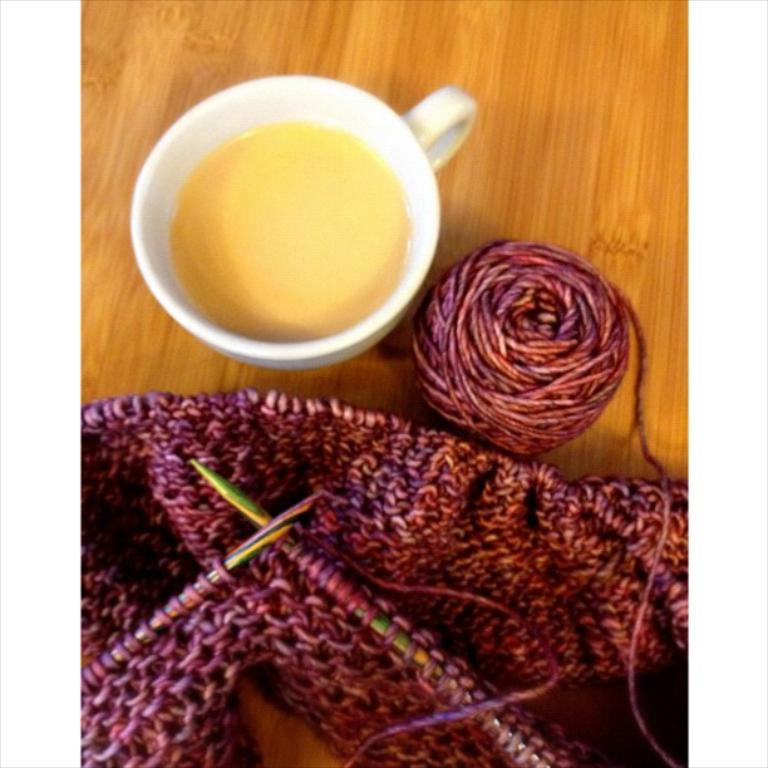What type of surface is visible in the image? There is a wooden surface in the image. What is placed on the wooden surface? There is a cup of some drink and a roll of woolen thread on the wooden surface. What else can be seen on the wooden surface? There is a woolen cloth on the wooden surface. How is the woolen cloth being held in place? There are two pins attached to the woolen cloth. What degree of difficulty is the mind experiencing in the image? There is no mention of a mind or any difficulty in the image; it features a wooden surface with various objects on it. 